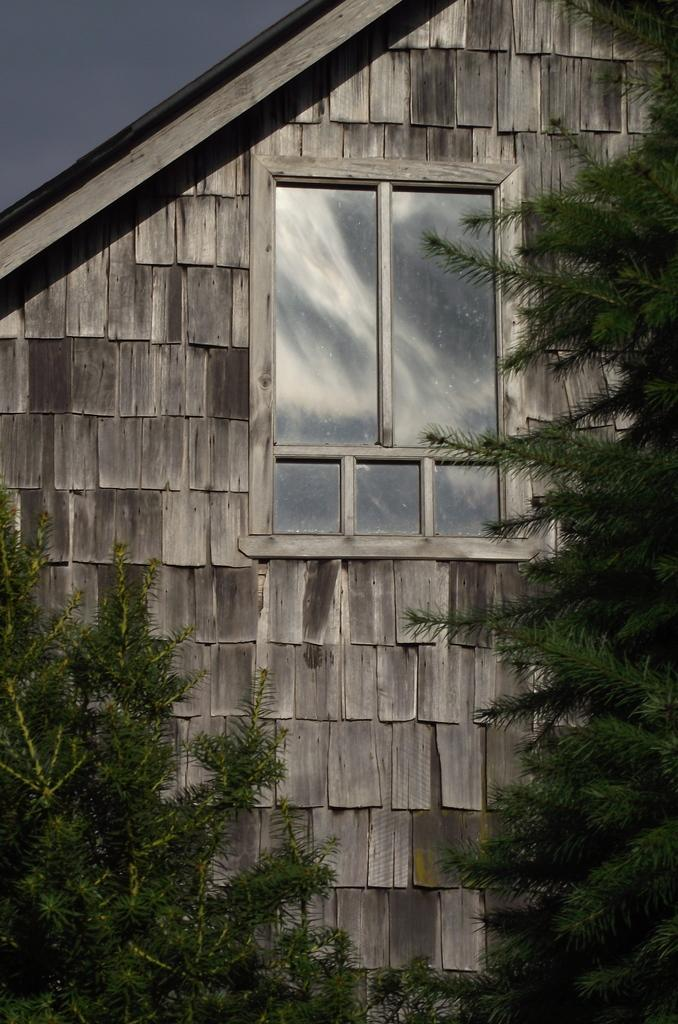What type of house is in the center of the image? There is a wooden house in the center of the image. Can you describe any specific features of the house? There is a window visible in the image. What else can be seen in the image besides the house? There are trees in the image. What color is the stocking hanging from the window in the image? There is no stocking hanging from the window in the image. What type of flesh can be seen on the trees in the image? There is no flesh present on the trees in the image; they are made of wood and leaves. 